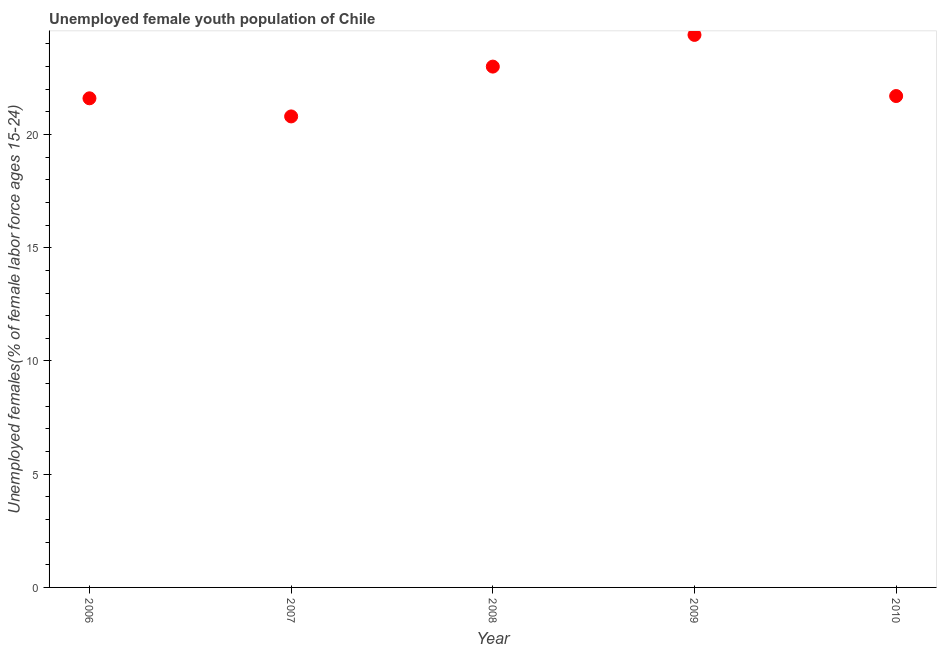What is the unemployed female youth in 2010?
Give a very brief answer. 21.7. Across all years, what is the maximum unemployed female youth?
Offer a terse response. 24.4. Across all years, what is the minimum unemployed female youth?
Ensure brevity in your answer.  20.8. In which year was the unemployed female youth minimum?
Offer a very short reply. 2007. What is the sum of the unemployed female youth?
Ensure brevity in your answer.  111.5. What is the difference between the unemployed female youth in 2006 and 2010?
Ensure brevity in your answer.  -0.1. What is the average unemployed female youth per year?
Provide a short and direct response. 22.3. What is the median unemployed female youth?
Provide a short and direct response. 21.7. Do a majority of the years between 2006 and 2007 (inclusive) have unemployed female youth greater than 2 %?
Provide a short and direct response. Yes. What is the ratio of the unemployed female youth in 2006 to that in 2009?
Offer a terse response. 0.89. Is the unemployed female youth in 2006 less than that in 2008?
Make the answer very short. Yes. What is the difference between the highest and the second highest unemployed female youth?
Give a very brief answer. 1.4. Is the sum of the unemployed female youth in 2007 and 2009 greater than the maximum unemployed female youth across all years?
Give a very brief answer. Yes. What is the difference between the highest and the lowest unemployed female youth?
Ensure brevity in your answer.  3.6. In how many years, is the unemployed female youth greater than the average unemployed female youth taken over all years?
Provide a short and direct response. 2. Does the unemployed female youth monotonically increase over the years?
Give a very brief answer. No. How many dotlines are there?
Provide a short and direct response. 1. How many years are there in the graph?
Offer a very short reply. 5. What is the title of the graph?
Your answer should be compact. Unemployed female youth population of Chile. What is the label or title of the X-axis?
Keep it short and to the point. Year. What is the label or title of the Y-axis?
Keep it short and to the point. Unemployed females(% of female labor force ages 15-24). What is the Unemployed females(% of female labor force ages 15-24) in 2006?
Your answer should be compact. 21.6. What is the Unemployed females(% of female labor force ages 15-24) in 2007?
Offer a terse response. 20.8. What is the Unemployed females(% of female labor force ages 15-24) in 2009?
Give a very brief answer. 24.4. What is the Unemployed females(% of female labor force ages 15-24) in 2010?
Offer a terse response. 21.7. What is the difference between the Unemployed females(% of female labor force ages 15-24) in 2006 and 2007?
Your answer should be compact. 0.8. What is the difference between the Unemployed females(% of female labor force ages 15-24) in 2006 and 2009?
Provide a short and direct response. -2.8. What is the difference between the Unemployed females(% of female labor force ages 15-24) in 2006 and 2010?
Your response must be concise. -0.1. What is the difference between the Unemployed females(% of female labor force ages 15-24) in 2007 and 2008?
Keep it short and to the point. -2.2. What is the difference between the Unemployed females(% of female labor force ages 15-24) in 2008 and 2009?
Offer a terse response. -1.4. What is the difference between the Unemployed females(% of female labor force ages 15-24) in 2009 and 2010?
Keep it short and to the point. 2.7. What is the ratio of the Unemployed females(% of female labor force ages 15-24) in 2006 to that in 2007?
Offer a terse response. 1.04. What is the ratio of the Unemployed females(% of female labor force ages 15-24) in 2006 to that in 2008?
Keep it short and to the point. 0.94. What is the ratio of the Unemployed females(% of female labor force ages 15-24) in 2006 to that in 2009?
Offer a very short reply. 0.89. What is the ratio of the Unemployed females(% of female labor force ages 15-24) in 2006 to that in 2010?
Your answer should be very brief. 0.99. What is the ratio of the Unemployed females(% of female labor force ages 15-24) in 2007 to that in 2008?
Give a very brief answer. 0.9. What is the ratio of the Unemployed females(% of female labor force ages 15-24) in 2007 to that in 2009?
Offer a very short reply. 0.85. What is the ratio of the Unemployed females(% of female labor force ages 15-24) in 2008 to that in 2009?
Your response must be concise. 0.94. What is the ratio of the Unemployed females(% of female labor force ages 15-24) in 2008 to that in 2010?
Ensure brevity in your answer.  1.06. What is the ratio of the Unemployed females(% of female labor force ages 15-24) in 2009 to that in 2010?
Keep it short and to the point. 1.12. 